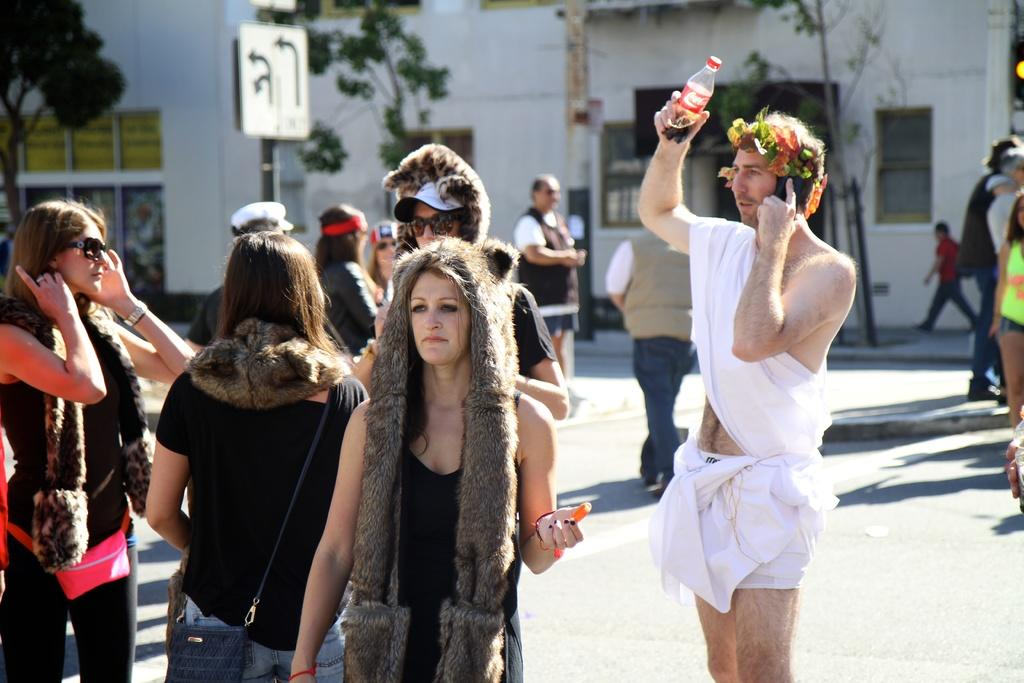What is happening on the road in the image? There is a crowd on the road in the image. What can be seen in the background of the image? There are buildings, trees, boards, and windows in the background of the image. What is the weather like in the image? The image was taken during a sunny day. How many strands of hair can be seen on the crowd in the image? There are no strands of hair visible on the crowd in the image, as it is a group of people and not an individual. 